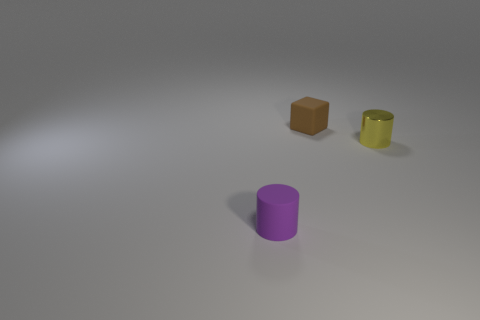There is a tiny thing that is in front of the small cube and behind the small purple matte object; what is its material?
Your answer should be compact. Metal. How big is the yellow metallic cylinder right of the matte thing to the left of the tiny matte thing behind the purple thing?
Your answer should be compact. Small. Is the number of brown rubber objects greater than the number of tiny purple matte balls?
Your response must be concise. Yes. Do the object that is on the left side of the matte block and the brown object have the same material?
Give a very brief answer. Yes. Are there fewer yellow cylinders than purple spheres?
Give a very brief answer. No. Are there any things to the right of the small object right of the matte object that is behind the tiny shiny thing?
Your answer should be compact. No. Do the small thing that is in front of the yellow cylinder and the yellow thing have the same shape?
Make the answer very short. Yes. Are there more tiny yellow cylinders left of the yellow shiny thing than tiny matte things?
Make the answer very short. No. Are there any other things that are the same color as the rubber cylinder?
Keep it short and to the point. No. The cylinder that is on the left side of the rubber object behind the small cylinder that is on the right side of the tiny brown cube is what color?
Make the answer very short. Purple. 